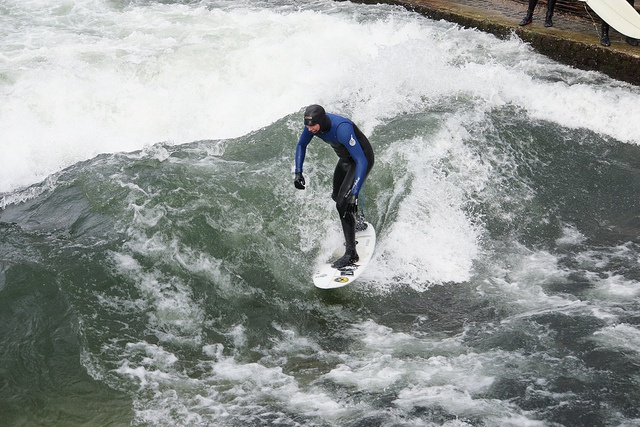Describe the objects in this image and their specific colors. I can see people in lightgray, black, gray, navy, and darkgray tones, surfboard in lightgray, gray, darkgray, and black tones, surfboard in lightgray, ivory, black, gray, and darkgray tones, people in lightgray, black, gray, and maroon tones, and people in lightgray, black, and gray tones in this image. 